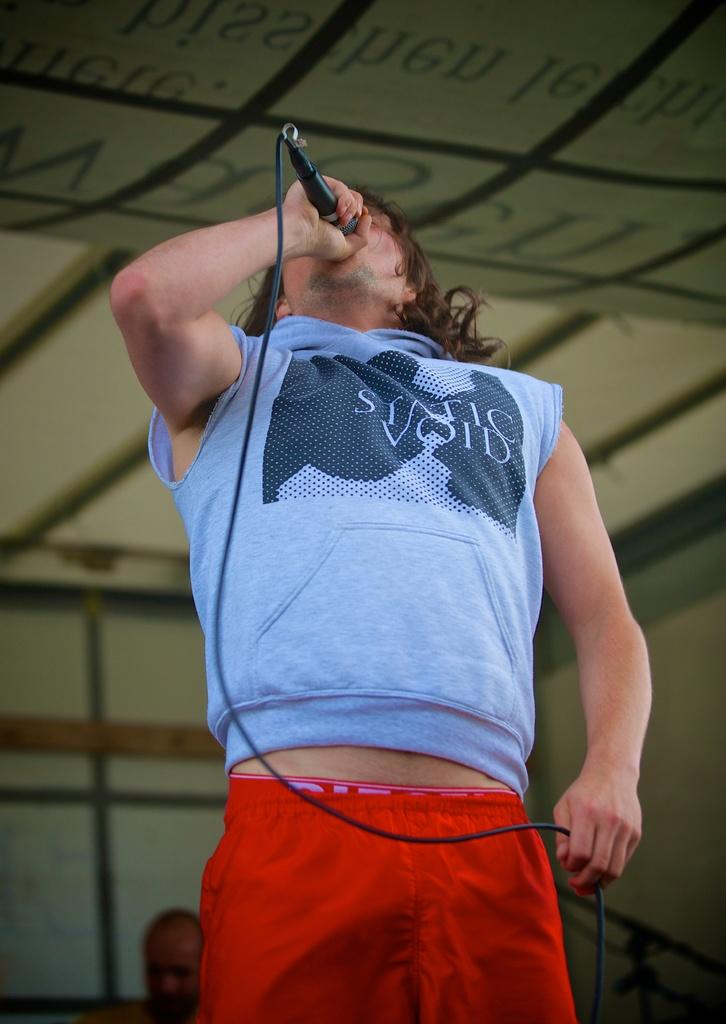What is the second word on the shirt?
Offer a terse response. Void. What is the first world on the shirt?
Offer a very short reply. Static. 